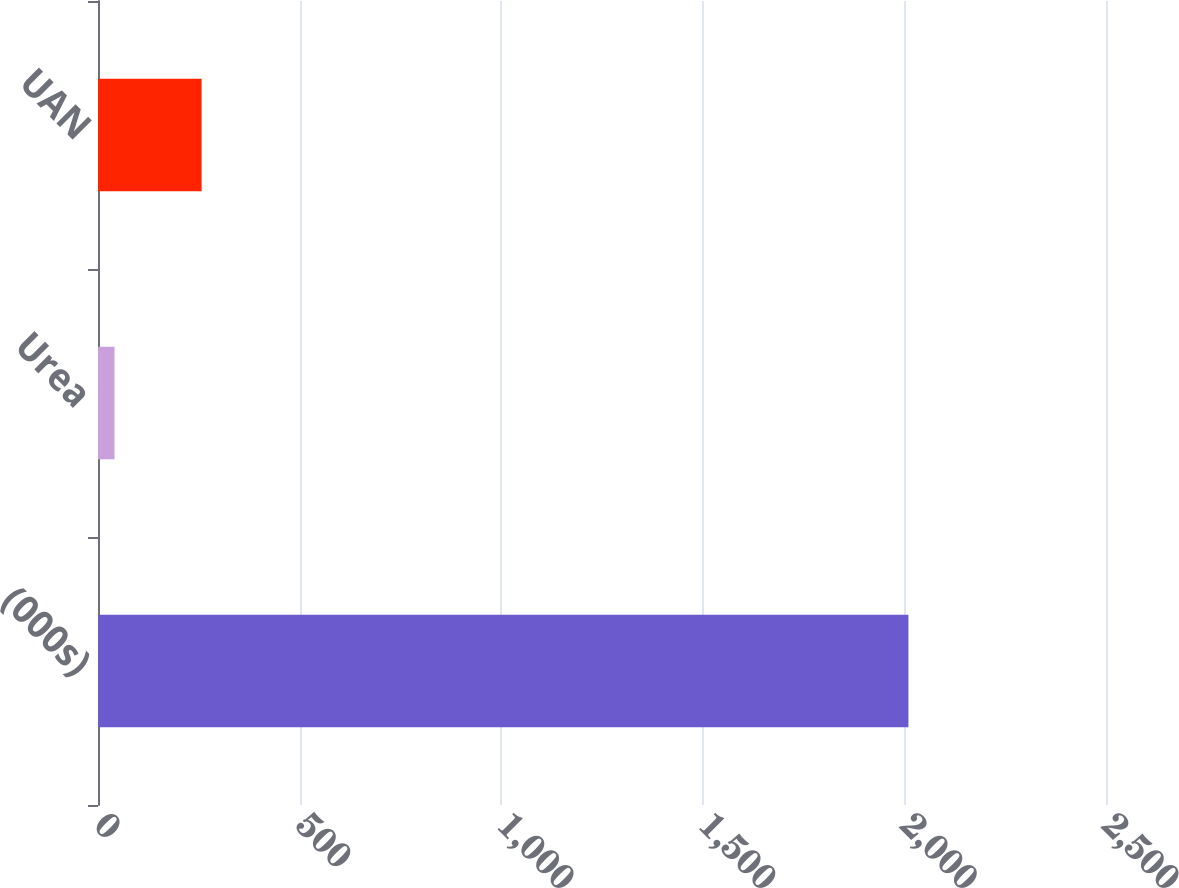<chart> <loc_0><loc_0><loc_500><loc_500><bar_chart><fcel>(000s)<fcel>Urea<fcel>UAN<nl><fcel>2010<fcel>41<fcel>257<nl></chart> 